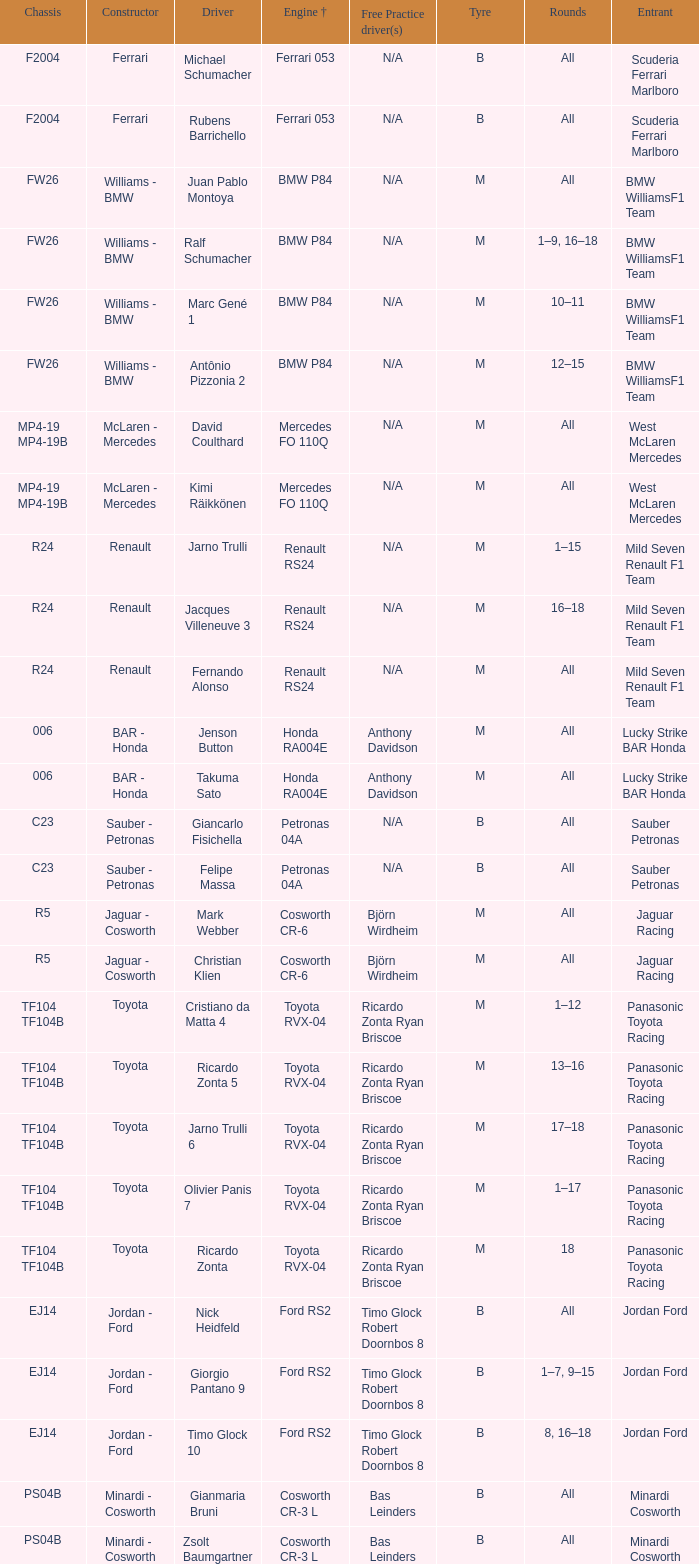What kind of chassis does Ricardo Zonta have? TF104 TF104B. 